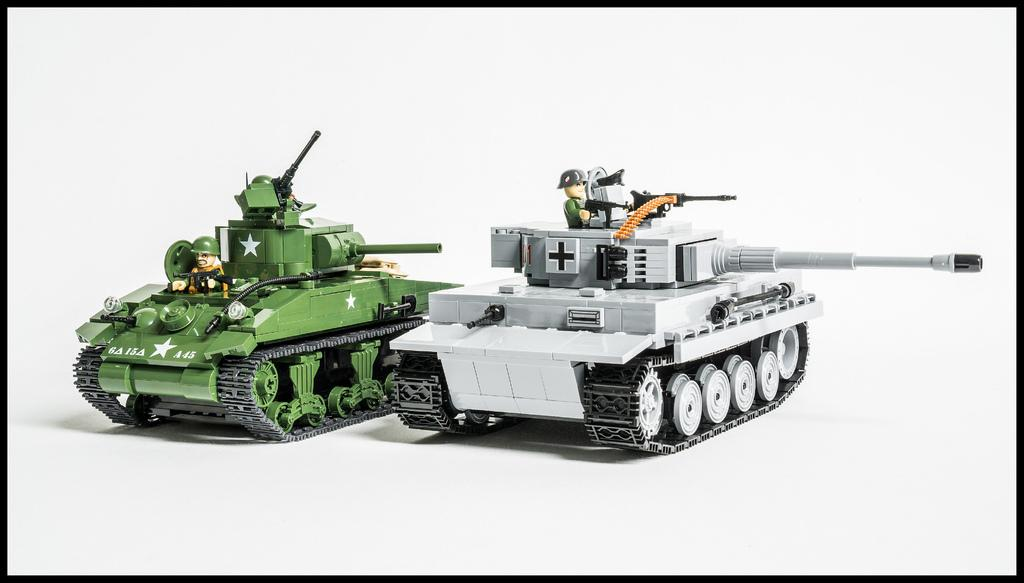What type of toys are present in the image? There are two toy tankers in the image. Are there any people in the image? Yes, there are persons in the image. What day of the week is depicted in the image? The day of the week is not depicted in the image, as it does not contain any information about a specific day. 